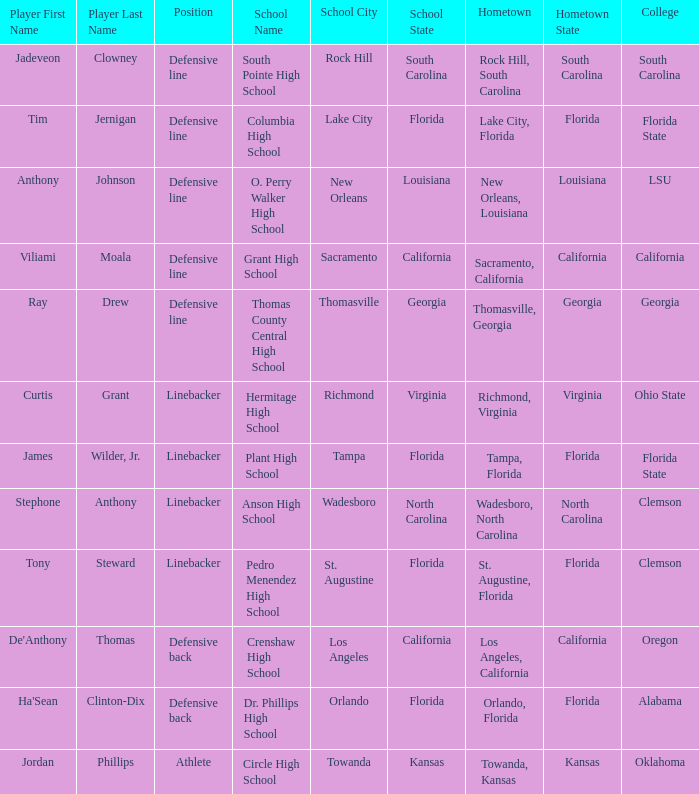What position is for Plant high school? Linebacker. 